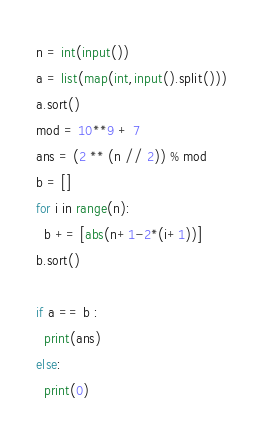<code> <loc_0><loc_0><loc_500><loc_500><_Python_>n = int(input())
a = list(map(int,input().split()))
a.sort()
mod = 10**9 + 7
ans = (2 ** (n // 2)) % mod
b = []
for i in range(n):
  b += [abs(n+1-2*(i+1))]
b.sort()

if a == b :
  print(ans)
else:
  print(0)

</code> 